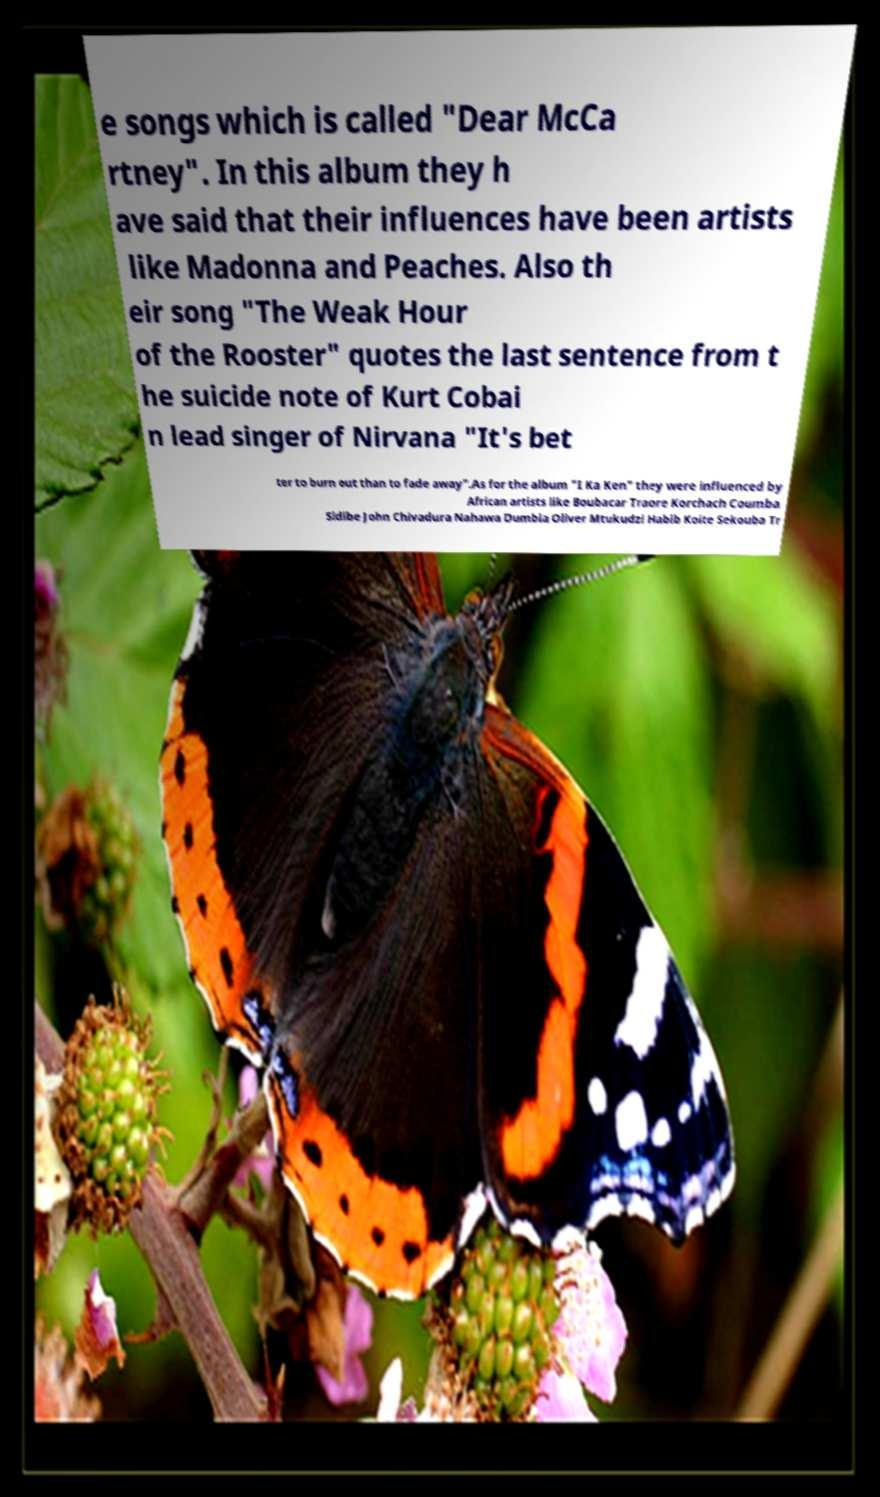Could you extract and type out the text from this image? e songs which is called "Dear McCa rtney". In this album they h ave said that their influences have been artists like Madonna and Peaches. Also th eir song "The Weak Hour of the Rooster" quotes the last sentence from t he suicide note of Kurt Cobai n lead singer of Nirvana "It's bet ter to burn out than to fade away".As for the album "I Ka Ken" they were influenced by African artists like Boubacar Traore Korchach Coumba Sidibe John Chivadura Nahawa Dumbia Oliver Mtukudzi Habib Koite Sekouba Tr 